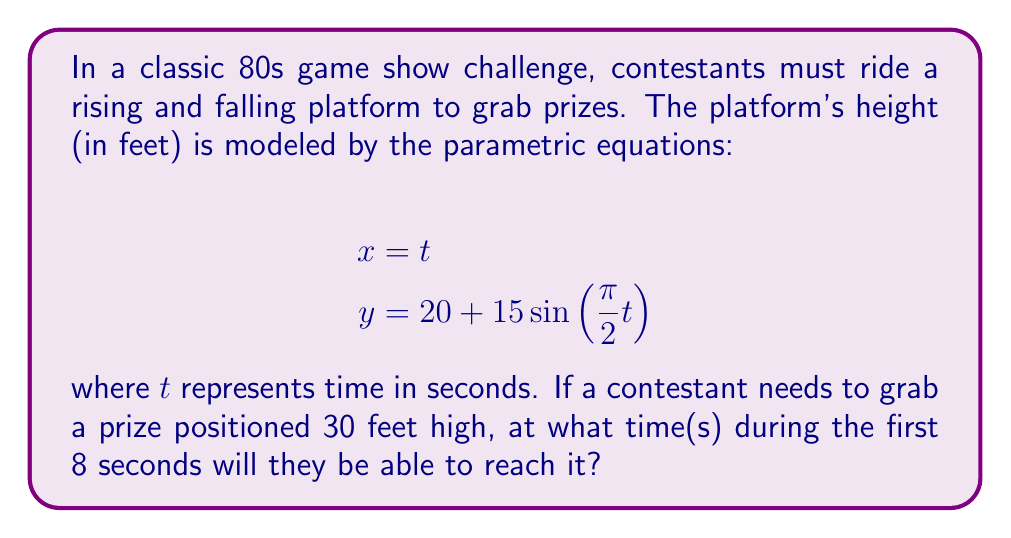Can you answer this question? To solve this problem, we need to follow these steps:

1) We're looking for the time(s) when the platform's height (y) equals 30 feet.

2) Set up the equation:
   $$30 = 20 + 15\sin(\frac{\pi}{2}t)$$

3) Solve for $\sin(\frac{\pi}{2}t)$:
   $$10 = 15\sin(\frac{\pi}{2}t)$$
   $$\frac{2}{3} = \sin(\frac{\pi}{2}t)$$

4) Take the inverse sine (arcsin) of both sides:
   $$\arcsin(\frac{2}{3}) = \frac{\pi}{2}t$$

5) Solve for t:
   $$t = \frac{2}{\pi}\arcsin(\frac{2}{3}) \approx 0.7297 \text{ seconds}$$

6) This gives us the first time the platform reaches 30 feet. To find the second time within the 8-second interval, we need to consider the periodicity of the sine function.

7) The period of $\sin(\frac{\pi}{2}t)$ is 4 seconds. So, the platform will reach 30 feet again 4 seconds later:
   $$0.7297 + 4 = 4.7297 \text{ seconds}$$

Therefore, the platform will reach 30 feet at approximately 0.7297 seconds and 4.7297 seconds within the first 8 seconds.
Answer: The contestant will be able to reach the prize at approximately 0.7297 seconds and 4.7297 seconds. 